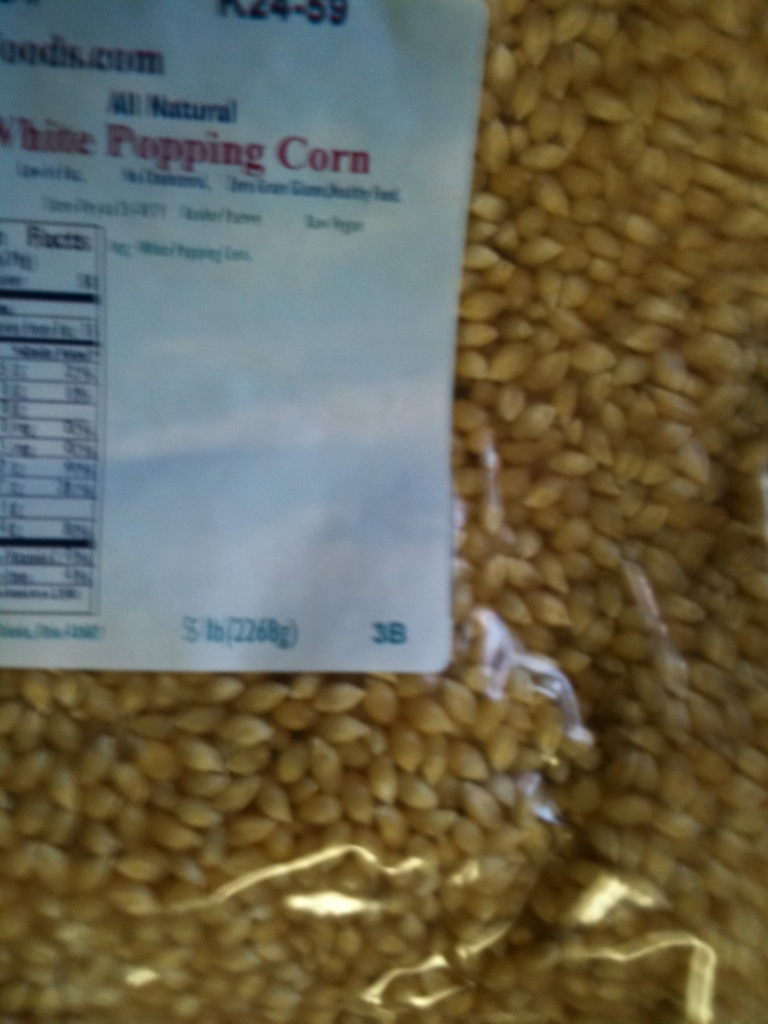Describe a scenario in which this popping corn could be used in a creative art project. One creative art project using this popping corn could be designing an elaborate mosaic. Each popped kernel could be dyed in various colors and then arranged to create a vibrant and textured piece of art. Imagine creating a beautiful landscape or a detailed portrait where every part of the image is made from colorful pieces of popcorn. 